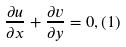Convert formula to latex. <formula><loc_0><loc_0><loc_500><loc_500>\frac { \partial u } { \partial x } + \frac { \partial v } { \partial y } = 0 , ( 1 )</formula> 